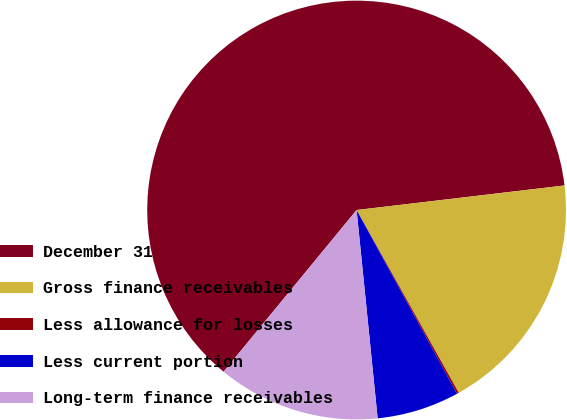<chart> <loc_0><loc_0><loc_500><loc_500><pie_chart><fcel>December 31<fcel>Gross finance receivables<fcel>Less allowance for losses<fcel>Less current portion<fcel>Long-term finance receivables<nl><fcel>62.17%<fcel>18.76%<fcel>0.15%<fcel>6.36%<fcel>12.56%<nl></chart> 